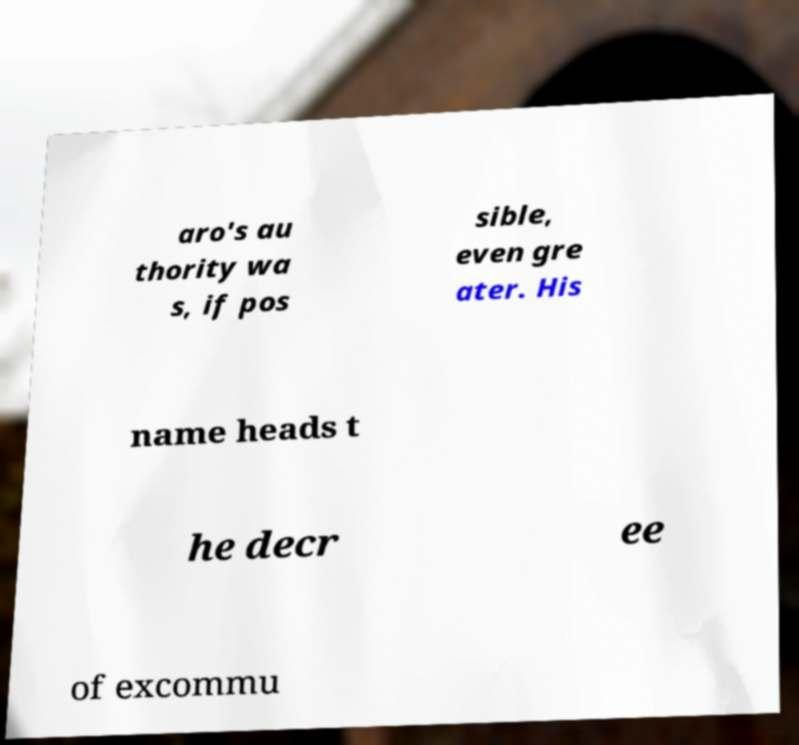Can you read and provide the text displayed in the image?This photo seems to have some interesting text. Can you extract and type it out for me? aro's au thority wa s, if pos sible, even gre ater. His name heads t he decr ee of excommu 